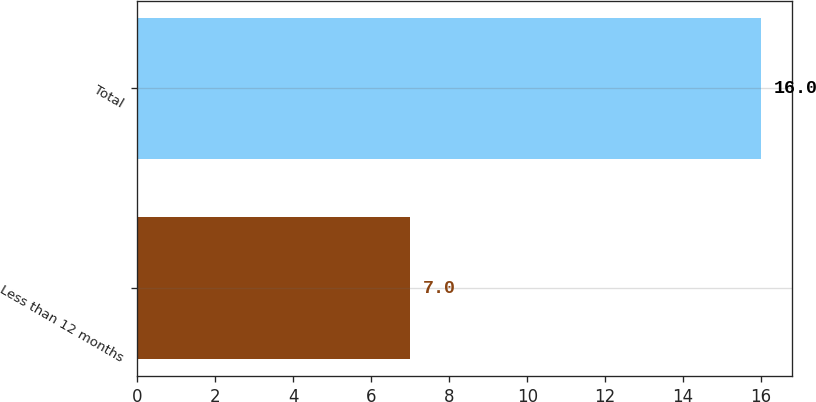Convert chart. <chart><loc_0><loc_0><loc_500><loc_500><bar_chart><fcel>Less than 12 months<fcel>Total<nl><fcel>7<fcel>16<nl></chart> 